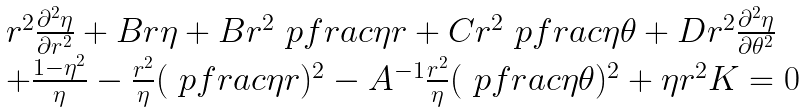Convert formula to latex. <formula><loc_0><loc_0><loc_500><loc_500>\begin{array} { l } r ^ { 2 } \frac { \partial ^ { 2 } \eta } { \partial r ^ { 2 } } + B r \eta + B r ^ { 2 } \ p f r a c { \eta } { r } + C r ^ { 2 } \ p f r a c { \eta } { \theta } + D r ^ { 2 } \frac { \partial ^ { 2 } \eta } { \partial \theta ^ { 2 } } \\ + \frac { 1 - \eta ^ { 2 } } { \eta } - \frac { r ^ { 2 } } { \eta } ( \ p f r a c { \eta } { r } ) ^ { 2 } - A ^ { - 1 } \frac { r ^ { 2 } } { \eta } ( \ p f r a c { \eta } { \theta } ) ^ { 2 } + \eta r ^ { 2 } K = 0 \end{array}</formula> 